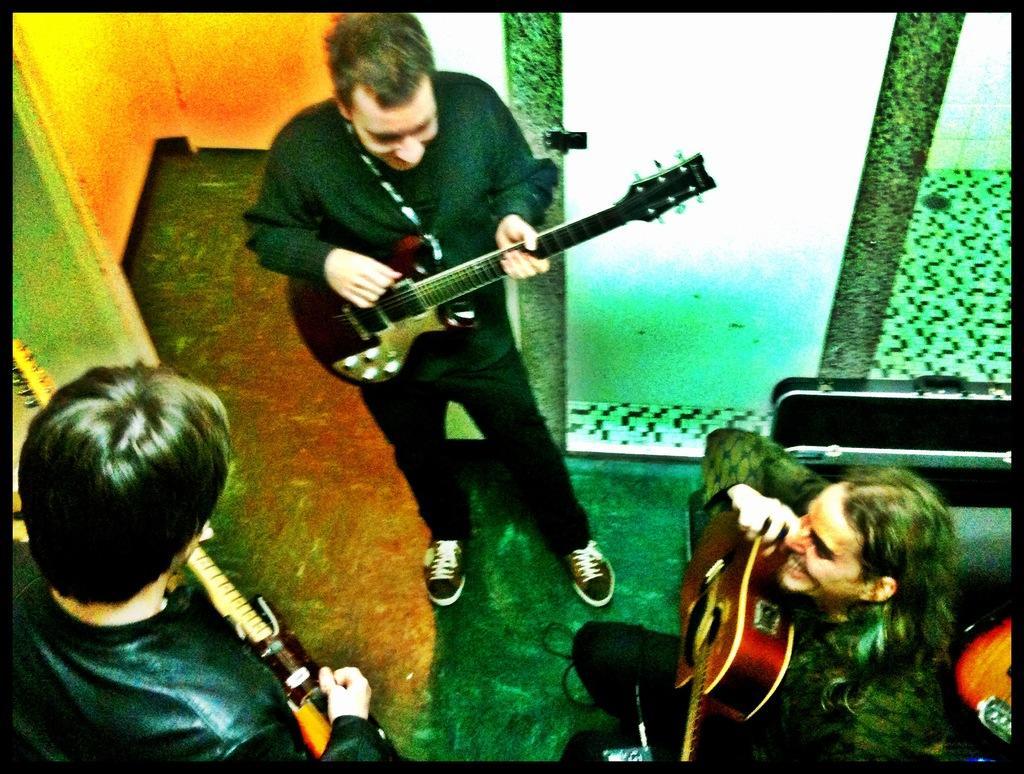Could you give a brief overview of what you see in this image? The picture has total three people , three of them are holding guitars, two of them are standing and one person is sitting in the background there is a green color glass beside it there is orange color wall. 